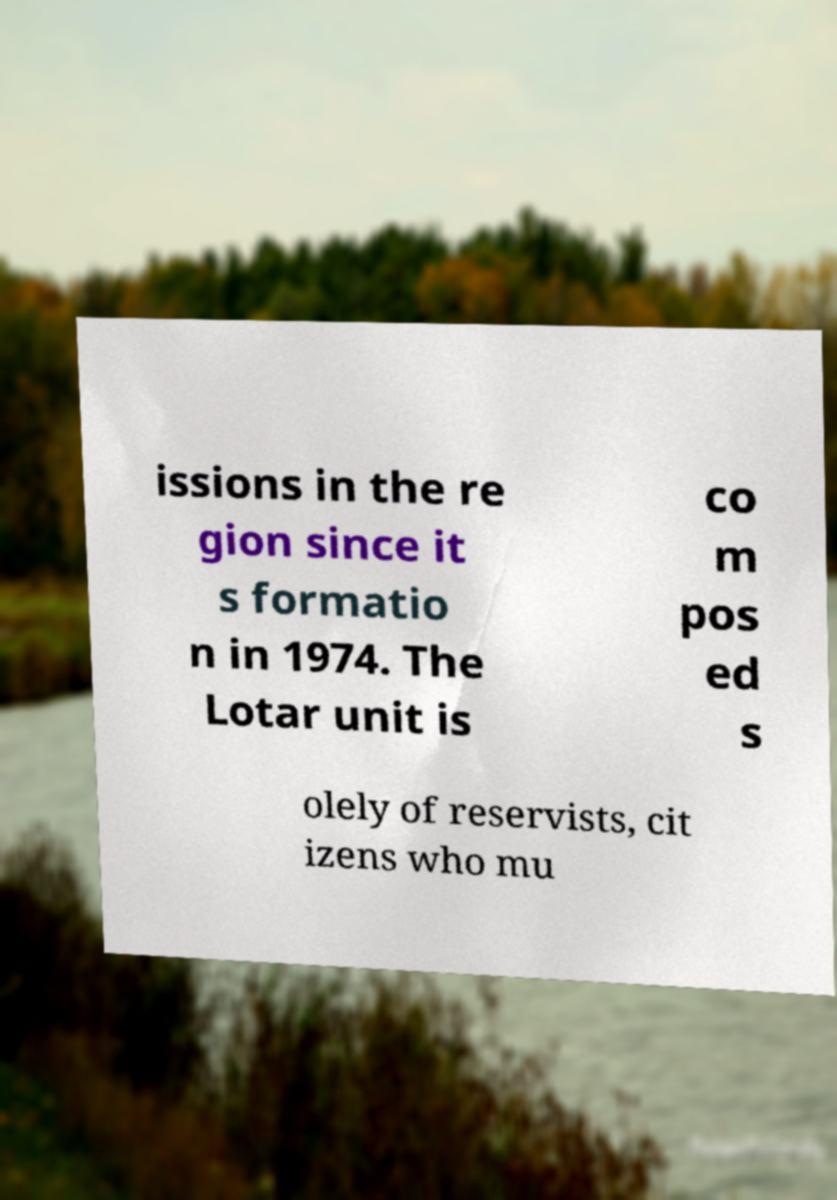Could you assist in decoding the text presented in this image and type it out clearly? issions in the re gion since it s formatio n in 1974. The Lotar unit is co m pos ed s olely of reservists, cit izens who mu 